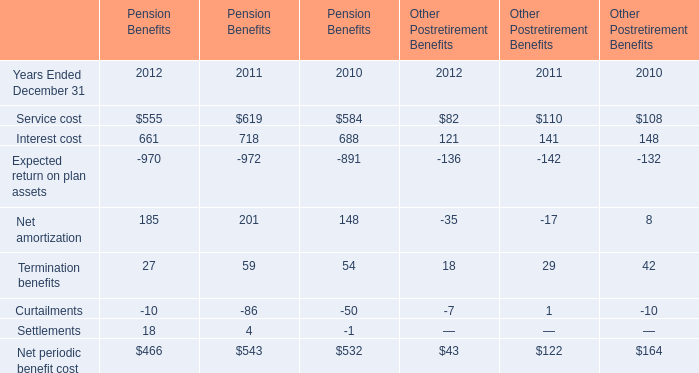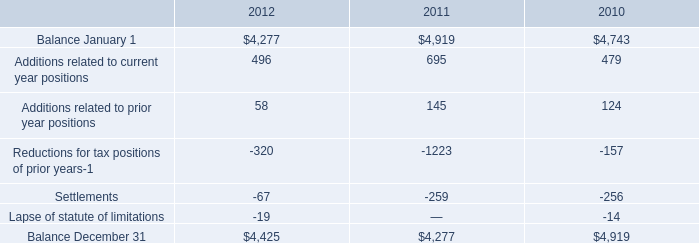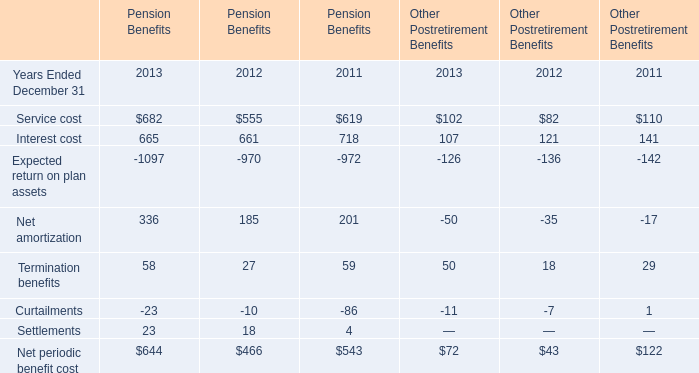How many years does Service cost for Pension Benefits stay lower than Interest cost for Pension Benefits? 
Answer: 3. 